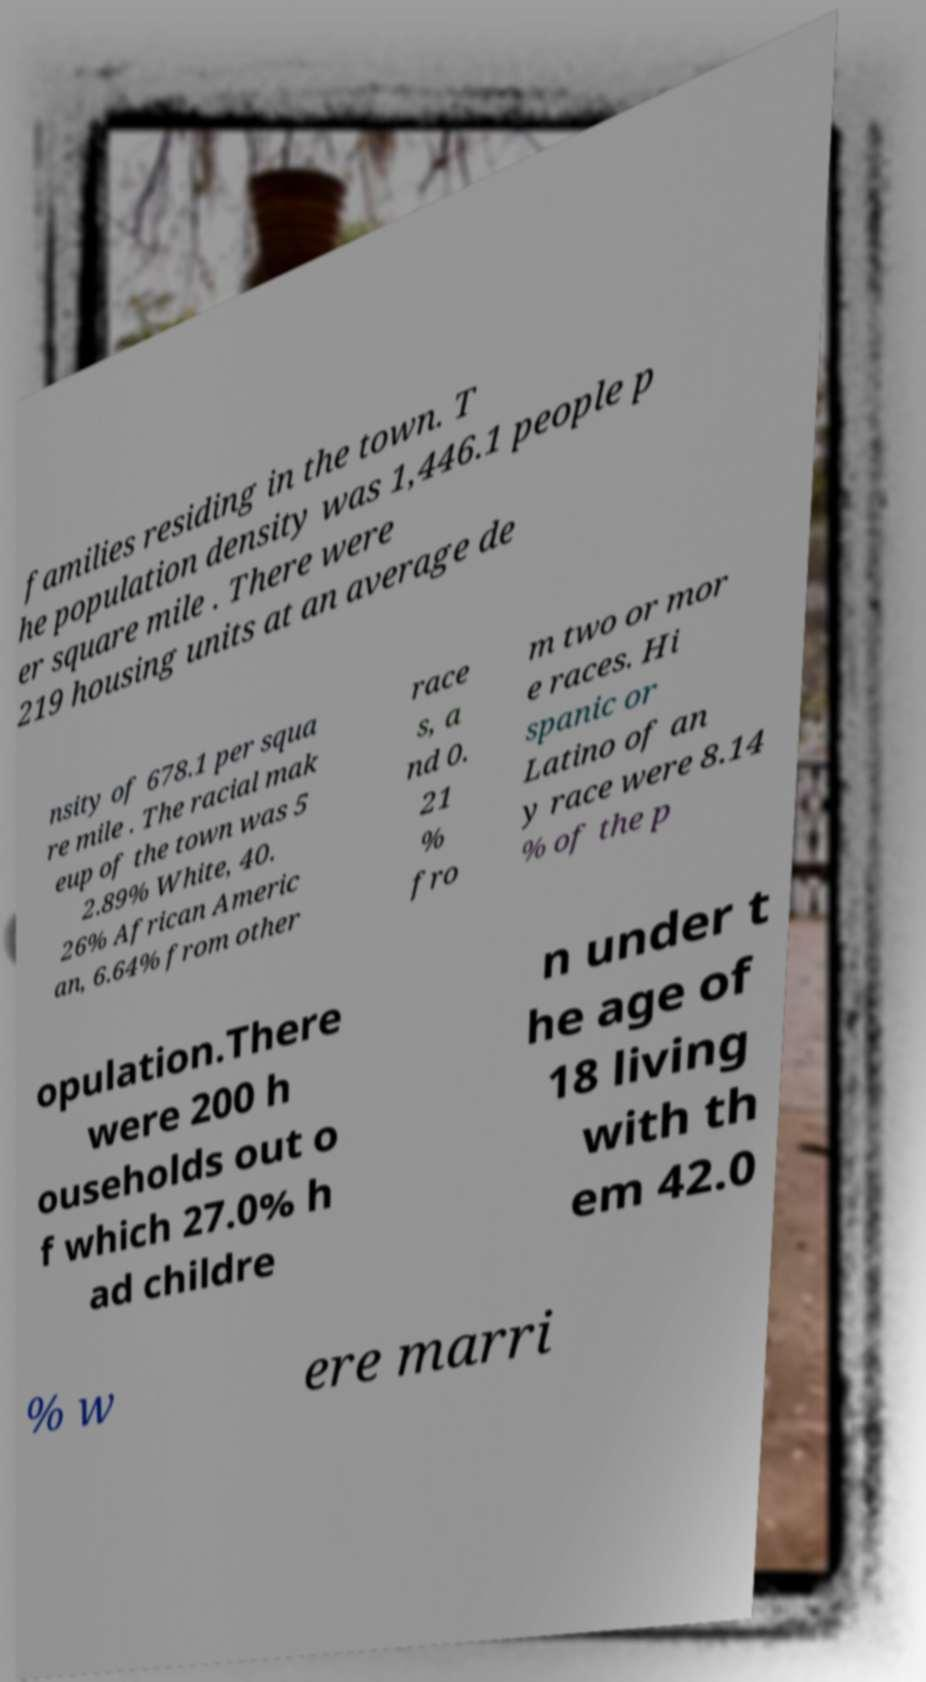Please read and relay the text visible in this image. What does it say? families residing in the town. T he population density was 1,446.1 people p er square mile . There were 219 housing units at an average de nsity of 678.1 per squa re mile . The racial mak eup of the town was 5 2.89% White, 40. 26% African Americ an, 6.64% from other race s, a nd 0. 21 % fro m two or mor e races. Hi spanic or Latino of an y race were 8.14 % of the p opulation.There were 200 h ouseholds out o f which 27.0% h ad childre n under t he age of 18 living with th em 42.0 % w ere marri 